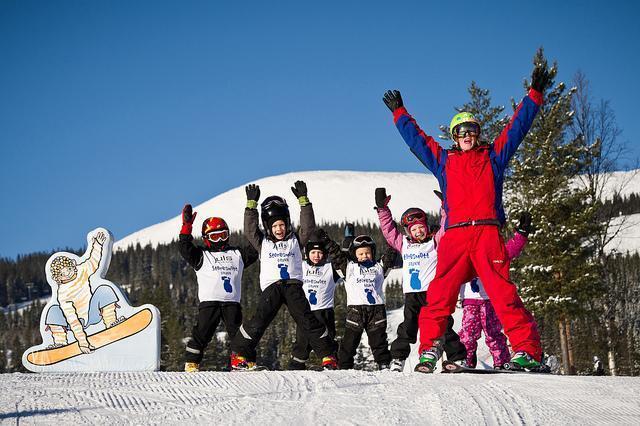How many people can you see?
Give a very brief answer. 7. 